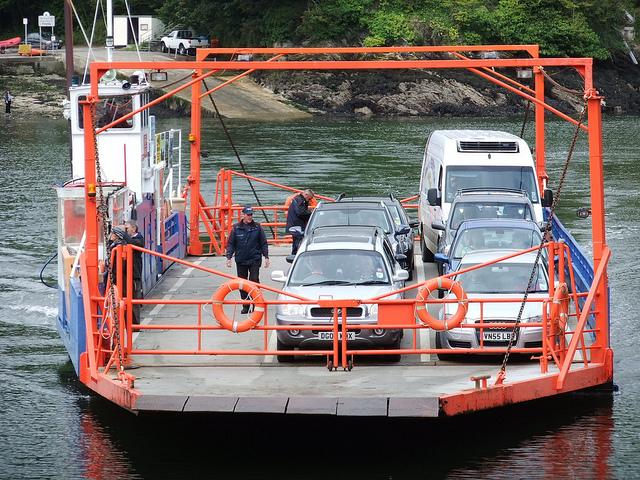Why are the vehicles on the boat?

Choices:
A) cross water
B) for sale
C) cleaning them
D) free ride cross water 